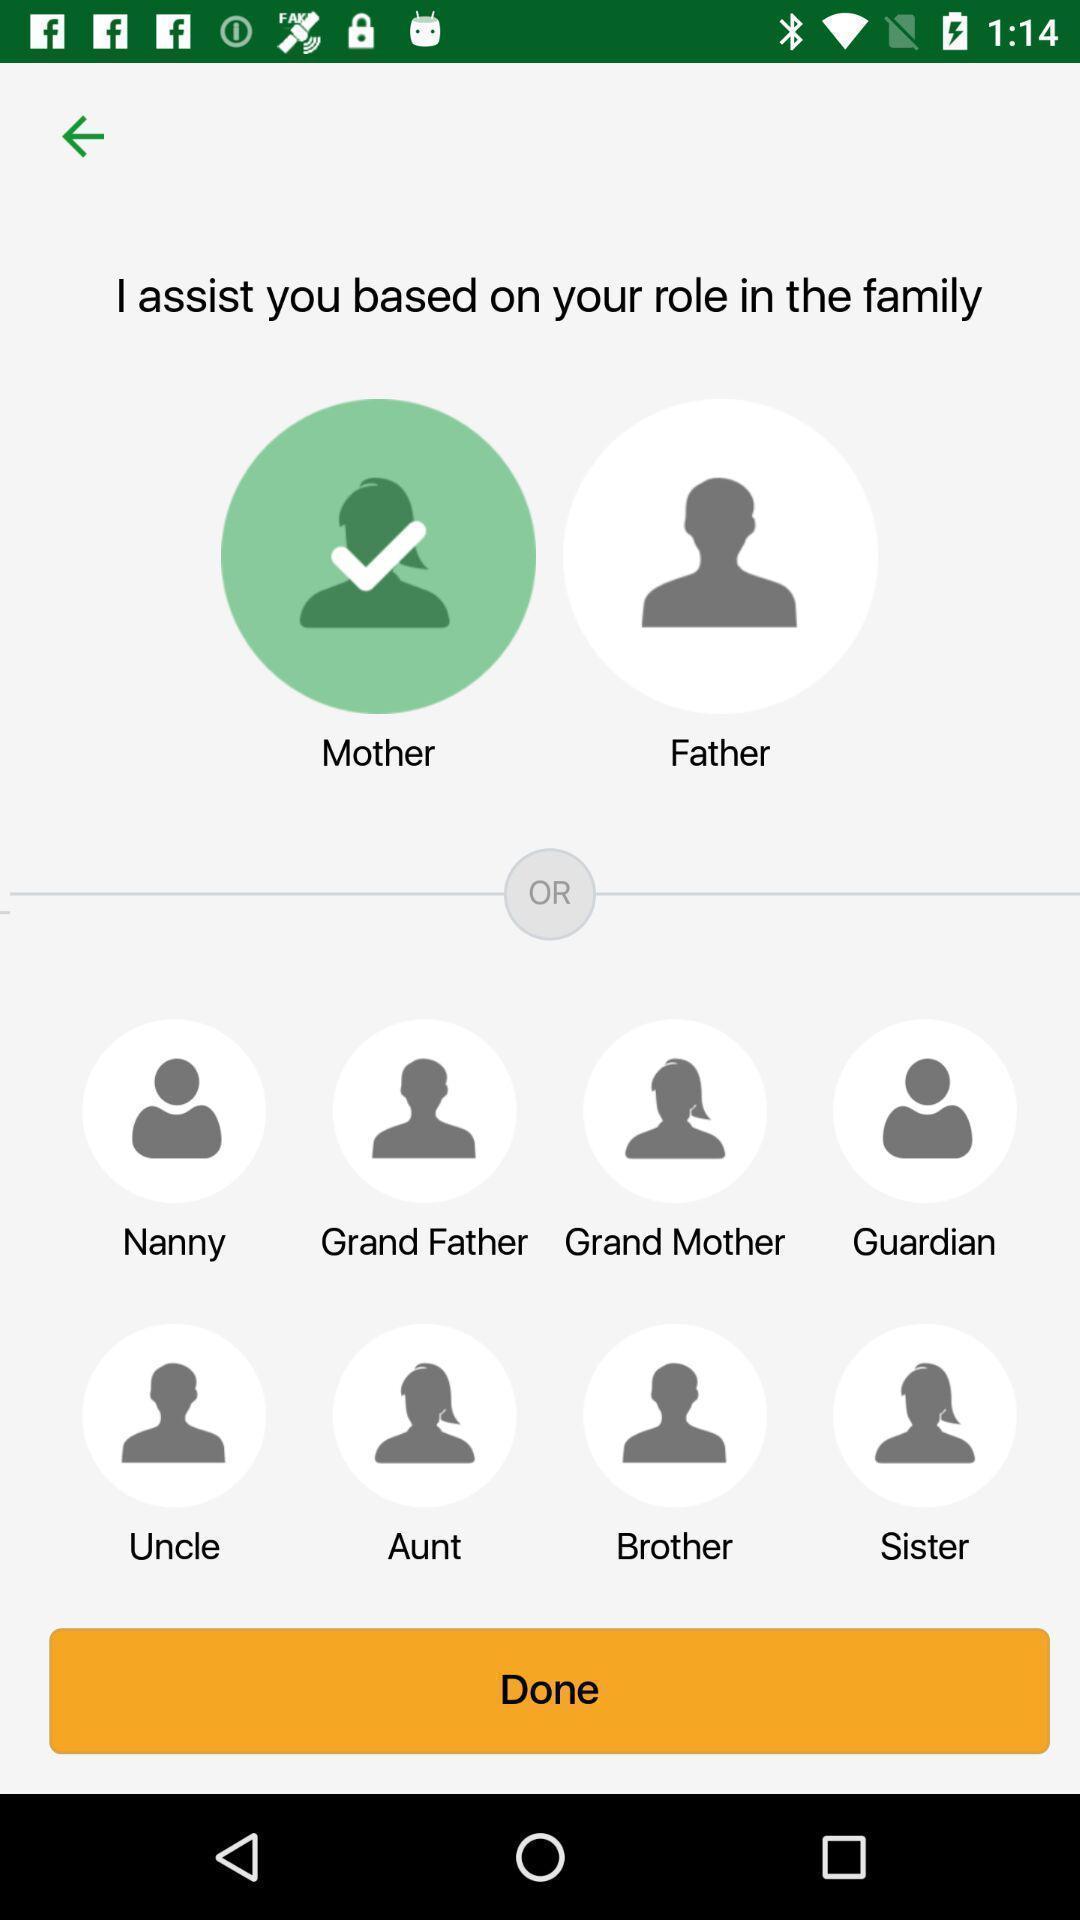Please provide a description for this image. Window displaying a parenting app. 